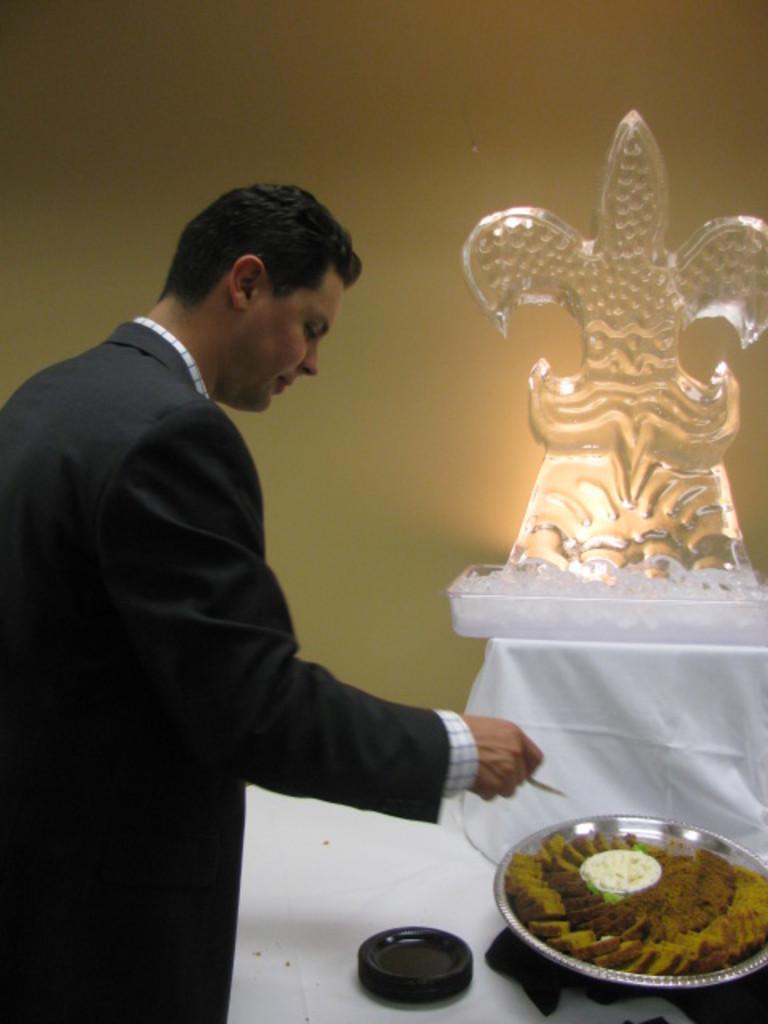Could you give a brief overview of what you see in this image? This image consists of a man wearing a black suit. In front of him, there is an idol and a tray of sweets. In the background, there is a wall. 